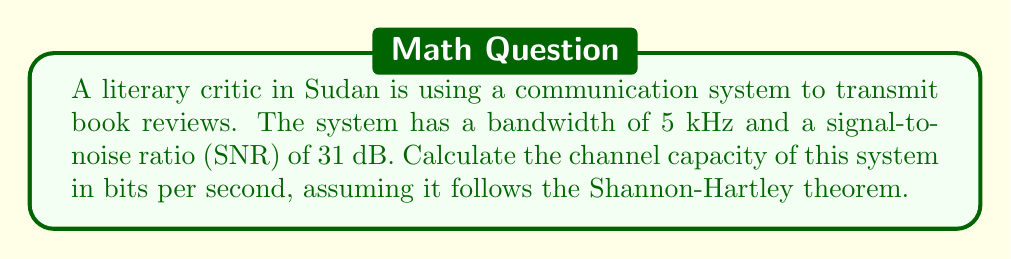Solve this math problem. To solve this problem, we'll use the Shannon-Hartley theorem, which gives the channel capacity for a communication system with Gaussian noise. The theorem states:

$$C = B \log_2(1 + SNR)$$

Where:
$C$ is the channel capacity in bits per second
$B$ is the bandwidth in Hertz
$SNR$ is the signal-to-noise ratio

Given:
- Bandwidth ($B$) = 5 kHz = 5000 Hz
- SNR = 31 dB

Step 1: Convert SNR from dB to linear scale
SNR in linear scale = $10^{(SNR_{dB}/10)}$
$SNR_{linear} = 10^{(31/10)} = 1258.93$

Step 2: Apply the Shannon-Hartley theorem
$$\begin{align}
C &= B \log_2(1 + SNR) \\
&= 5000 \log_2(1 + 1258.93) \\
&= 5000 \log_2(1259.93)
\end{align}$$

Step 3: Calculate the result
$$\begin{align}
C &= 5000 \times 10.30 \\
&= 51,500 \text{ bits per second}
\end{align}$$

Therefore, the channel capacity for transmitting literary reviews in this communication system is approximately 51,500 bits per second.
Answer: 51,500 bits per second 